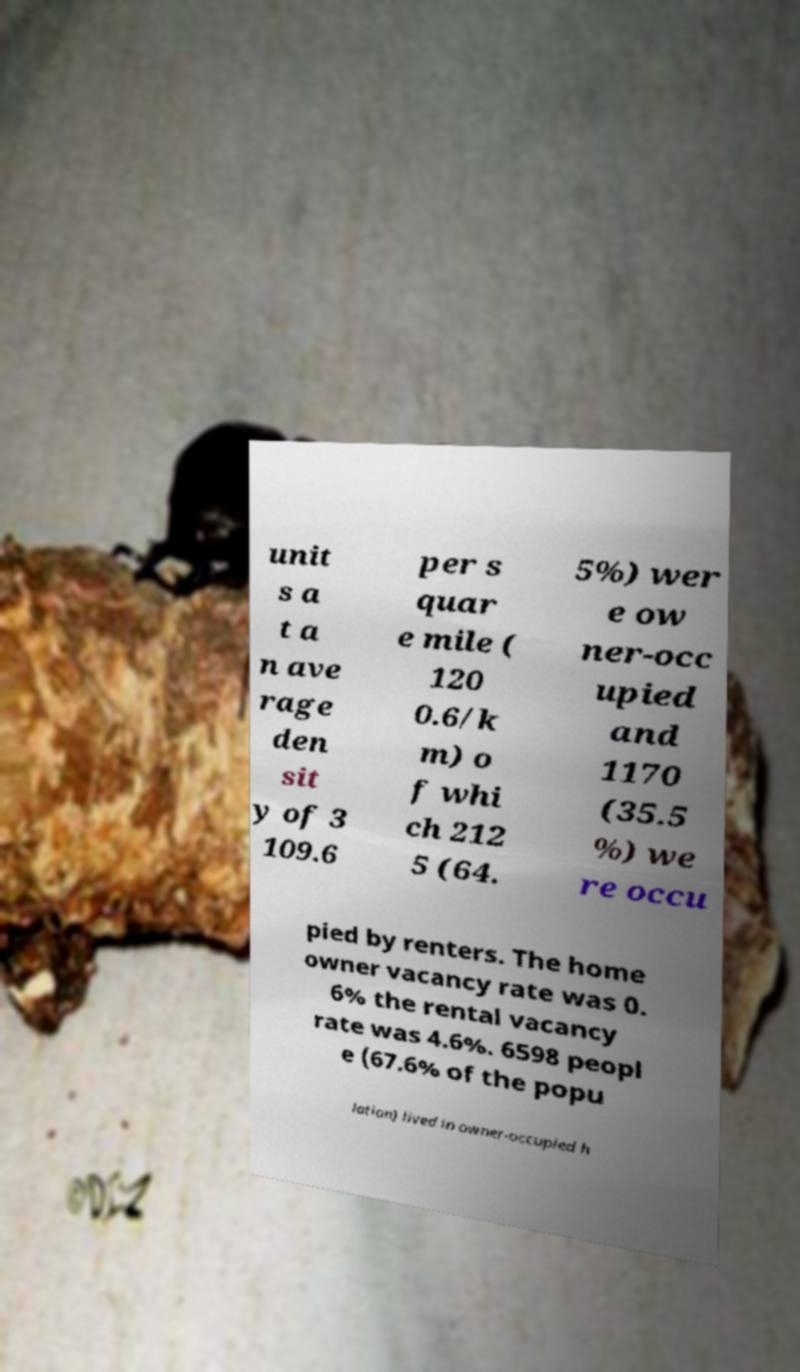Please identify and transcribe the text found in this image. unit s a t a n ave rage den sit y of 3 109.6 per s quar e mile ( 120 0.6/k m) o f whi ch 212 5 (64. 5%) wer e ow ner-occ upied and 1170 (35.5 %) we re occu pied by renters. The home owner vacancy rate was 0. 6% the rental vacancy rate was 4.6%. 6598 peopl e (67.6% of the popu lation) lived in owner-occupied h 